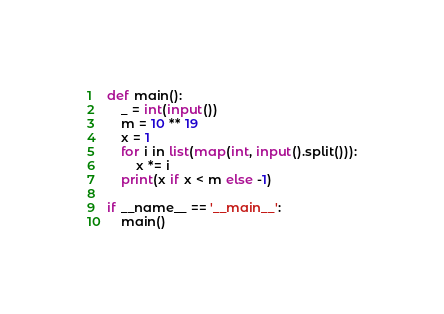<code> <loc_0><loc_0><loc_500><loc_500><_Python_>def main():
    _ = int(input())
    m = 10 ** 19
    x = 1
    for i in list(map(int, input().split())):
        x *= i
    print(x if x < m else -1)

if __name__ == '__main__':
    main()</code> 